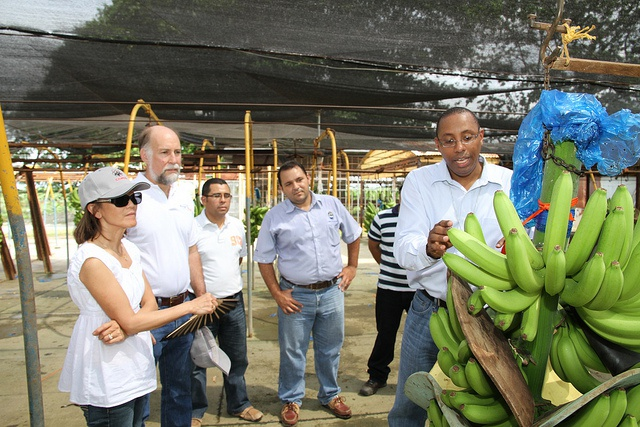Describe the objects in this image and their specific colors. I can see banana in lightgray, darkgreen, olive, black, and lightgreen tones, people in lightgray, tan, and black tones, people in lightgray, gray, lavender, and darkgray tones, people in lightgray, lavender, gray, brown, and black tones, and people in lightgray, white, black, tan, and navy tones in this image. 